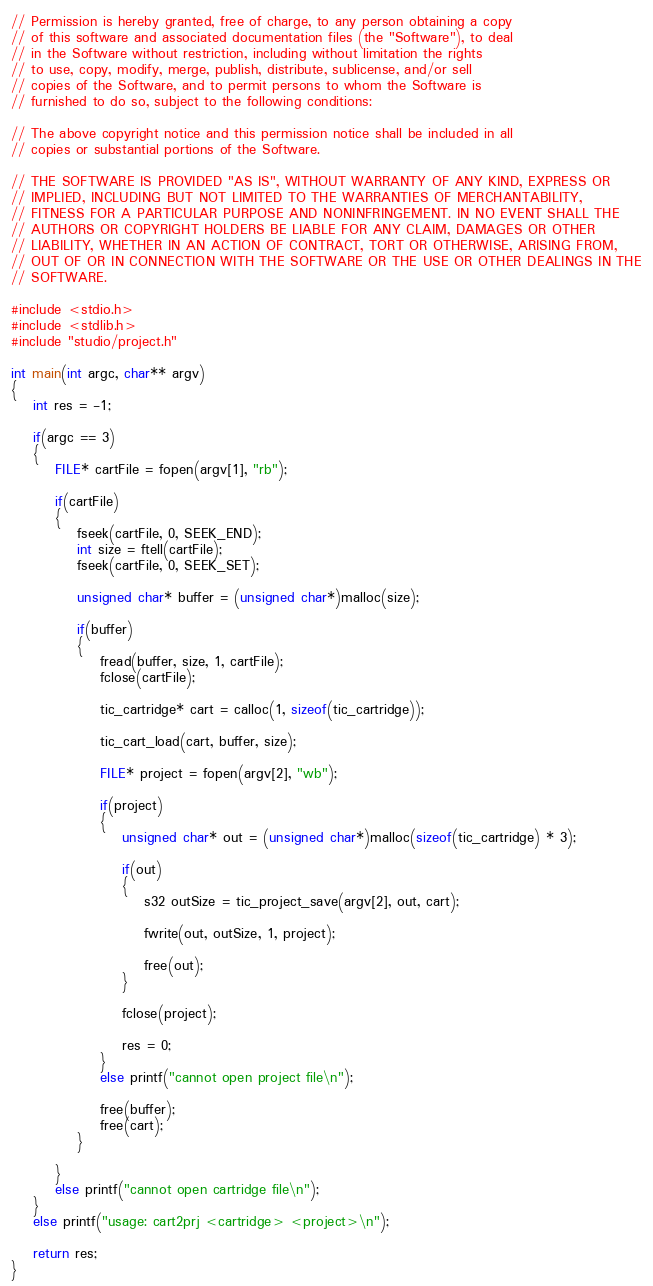Convert code to text. <code><loc_0><loc_0><loc_500><loc_500><_C_>// Permission is hereby granted, free of charge, to any person obtaining a copy
// of this software and associated documentation files (the "Software"), to deal
// in the Software without restriction, including without limitation the rights
// to use, copy, modify, merge, publish, distribute, sublicense, and/or sell
// copies of the Software, and to permit persons to whom the Software is
// furnished to do so, subject to the following conditions:

// The above copyright notice and this permission notice shall be included in all
// copies or substantial portions of the Software.

// THE SOFTWARE IS PROVIDED "AS IS", WITHOUT WARRANTY OF ANY KIND, EXPRESS OR
// IMPLIED, INCLUDING BUT NOT LIMITED TO THE WARRANTIES OF MERCHANTABILITY,
// FITNESS FOR A PARTICULAR PURPOSE AND NONINFRINGEMENT. IN NO EVENT SHALL THE
// AUTHORS OR COPYRIGHT HOLDERS BE LIABLE FOR ANY CLAIM, DAMAGES OR OTHER
// LIABILITY, WHETHER IN AN ACTION OF CONTRACT, TORT OR OTHERWISE, ARISING FROM,
// OUT OF OR IN CONNECTION WITH THE SOFTWARE OR THE USE OR OTHER DEALINGS IN THE
// SOFTWARE.

#include <stdio.h>
#include <stdlib.h>
#include "studio/project.h"

int main(int argc, char** argv)
{
	int res = -1;

	if(argc == 3)
	{
		FILE* cartFile = fopen(argv[1], "rb");

		if(cartFile)
		{
			fseek(cartFile, 0, SEEK_END);
			int size = ftell(cartFile);
			fseek(cartFile, 0, SEEK_SET);

			unsigned char* buffer = (unsigned char*)malloc(size);

			if(buffer)
			{
				fread(buffer, size, 1, cartFile);
				fclose(cartFile);

				tic_cartridge* cart = calloc(1, sizeof(tic_cartridge));

				tic_cart_load(cart, buffer, size);

				FILE* project = fopen(argv[2], "wb");

				if(project)
				{
					unsigned char* out = (unsigned char*)malloc(sizeof(tic_cartridge) * 3);

					if(out)
					{
						s32 outSize = tic_project_save(argv[2], out, cart);

						fwrite(out, outSize, 1, project);

						free(out);
					}

					fclose(project);

					res = 0;
				}
				else printf("cannot open project file\n");

				free(buffer);
				free(cart);
			}

		}
		else printf("cannot open cartridge file\n");
	}
	else printf("usage: cart2prj <cartridge> <project>\n");

	return res;
}
</code> 